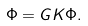<formula> <loc_0><loc_0><loc_500><loc_500>\Phi = G K \Phi .</formula> 